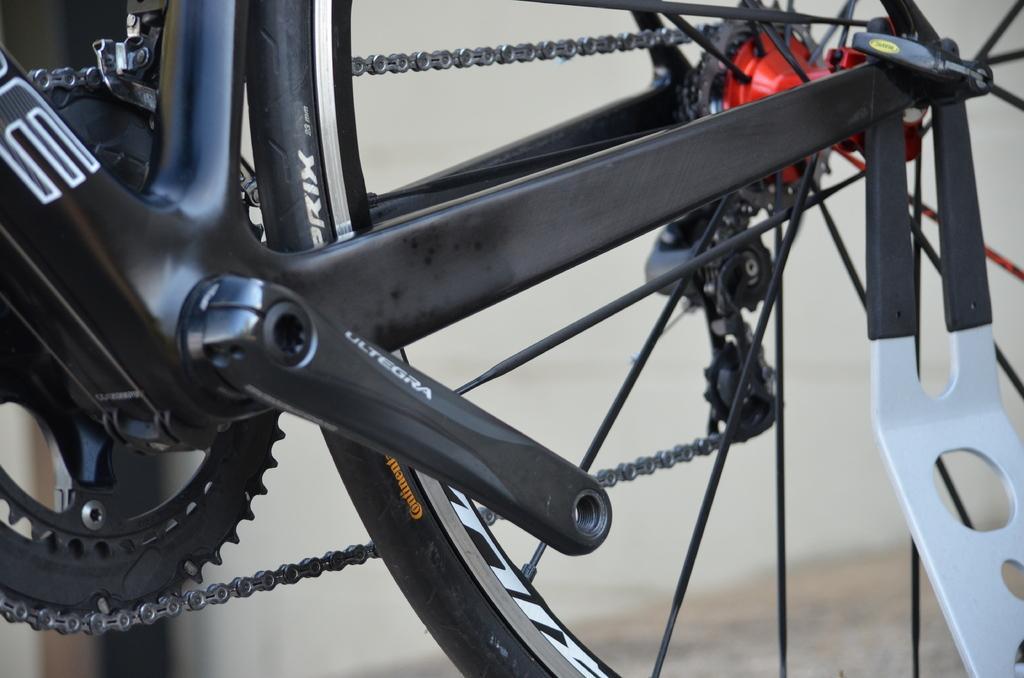Please provide a concise description of this image. In the center of the image, we can see a bicycle. 